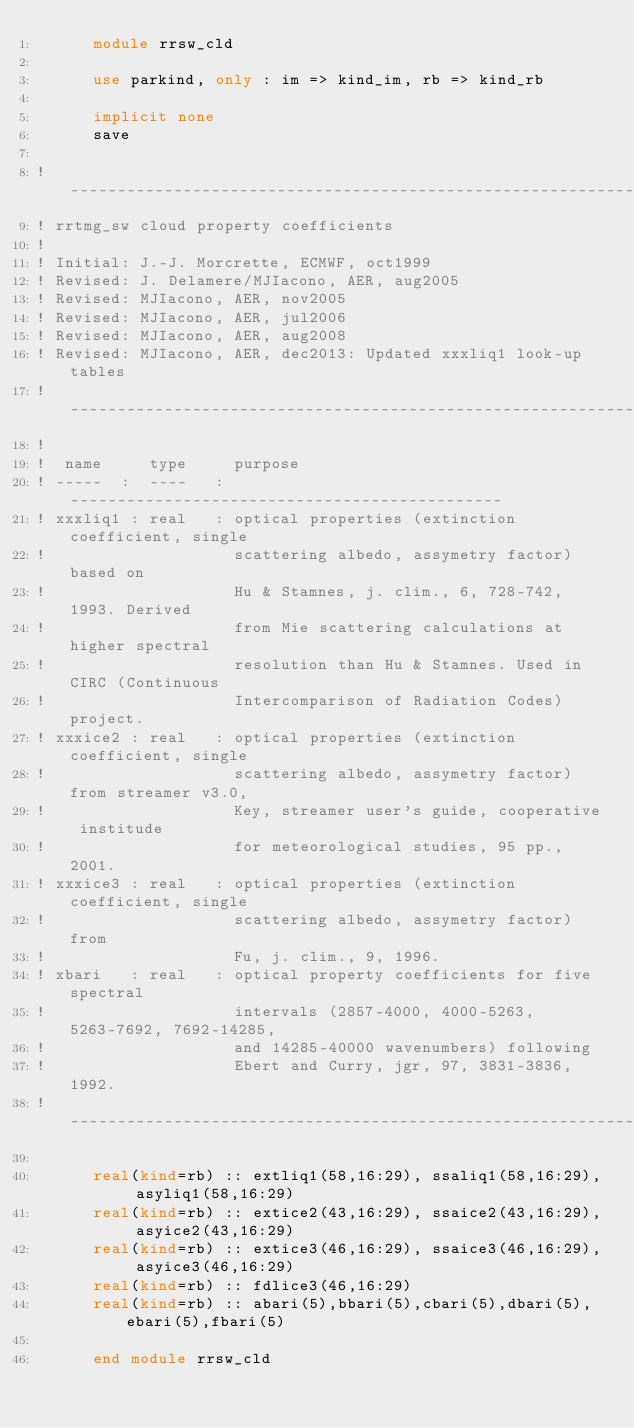Convert code to text. <code><loc_0><loc_0><loc_500><loc_500><_FORTRAN_>      module rrsw_cld

      use parkind, only : im => kind_im, rb => kind_rb

      implicit none
      save

!------------------------------------------------------------------
! rrtmg_sw cloud property coefficients
!
! Initial: J.-J. Morcrette, ECMWF, oct1999
! Revised: J. Delamere/MJIacono, AER, aug2005
! Revised: MJIacono, AER, nov2005
! Revised: MJIacono, AER, jul2006
! Revised: MJIacono, AER, aug2008
! Revised: MJIacono, AER, dec2013: Updated xxxliq1 look-up tables
!------------------------------------------------------------------
!
!  name     type     purpose
! -----  :  ----   : ----------------------------------------------
! xxxliq1 : real   : optical properties (extinction coefficient, single 
!                    scattering albedo, assymetry factor) based on 
!                    Hu & Stamnes, j. clim., 6, 728-742, 1993. Derived
!                    from Mie scattering calculations at higher spectral
!                    resolution than Hu & Stamnes. Used in CIRC (Continuous
!                    Intercomparison of Radiation Codes) project. 
! xxxice2 : real   : optical properties (extinction coefficient, single 
!                    scattering albedo, assymetry factor) from streamer v3.0,
!                    Key, streamer user's guide, cooperative institude 
!                    for meteorological studies, 95 pp., 2001.
! xxxice3 : real   : optical properties (extinction coefficient, single 
!                    scattering albedo, assymetry factor) from
!                    Fu, j. clim., 9, 1996.
! xbari   : real   : optical property coefficients for five spectral 
!                    intervals (2857-4000, 4000-5263, 5263-7692, 7692-14285,
!                    and 14285-40000 wavenumbers) following 
!                    Ebert and Curry, jgr, 97, 3831-3836, 1992.
!------------------------------------------------------------------

      real(kind=rb) :: extliq1(58,16:29), ssaliq1(58,16:29), asyliq1(58,16:29)
      real(kind=rb) :: extice2(43,16:29), ssaice2(43,16:29), asyice2(43,16:29)
      real(kind=rb) :: extice3(46,16:29), ssaice3(46,16:29), asyice3(46,16:29)
      real(kind=rb) :: fdlice3(46,16:29)
      real(kind=rb) :: abari(5),bbari(5),cbari(5),dbari(5),ebari(5),fbari(5)

      end module rrsw_cld

</code> 